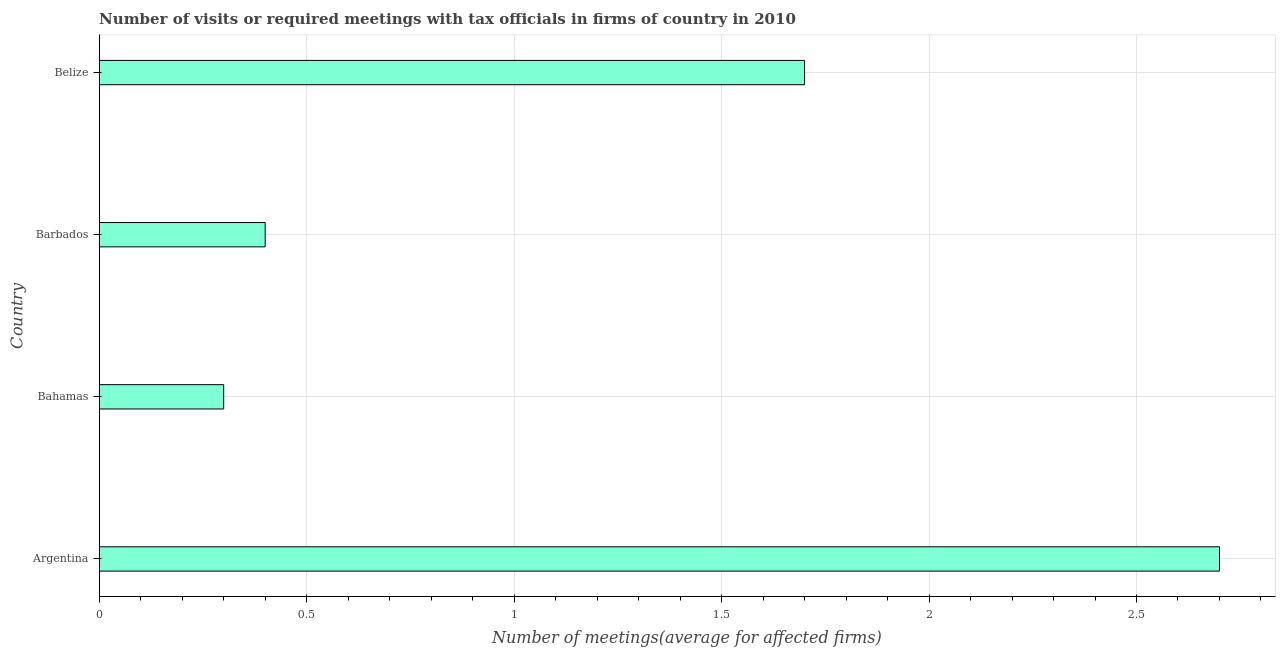Does the graph contain any zero values?
Your response must be concise. No. Does the graph contain grids?
Make the answer very short. Yes. What is the title of the graph?
Ensure brevity in your answer.  Number of visits or required meetings with tax officials in firms of country in 2010. What is the label or title of the X-axis?
Provide a short and direct response. Number of meetings(average for affected firms). What is the number of required meetings with tax officials in Barbados?
Provide a short and direct response. 0.4. Across all countries, what is the minimum number of required meetings with tax officials?
Keep it short and to the point. 0.3. In which country was the number of required meetings with tax officials minimum?
Ensure brevity in your answer.  Bahamas. What is the sum of the number of required meetings with tax officials?
Ensure brevity in your answer.  5.1. What is the difference between the number of required meetings with tax officials in Argentina and Belize?
Your answer should be very brief. 1. What is the average number of required meetings with tax officials per country?
Your response must be concise. 1.27. In how many countries, is the number of required meetings with tax officials greater than 0.9 ?
Provide a short and direct response. 2. Is the number of required meetings with tax officials in Argentina less than that in Belize?
Make the answer very short. No. Is the difference between the number of required meetings with tax officials in Argentina and Belize greater than the difference between any two countries?
Ensure brevity in your answer.  No. Is the sum of the number of required meetings with tax officials in Argentina and Barbados greater than the maximum number of required meetings with tax officials across all countries?
Your answer should be compact. Yes. What is the difference between the highest and the lowest number of required meetings with tax officials?
Your response must be concise. 2.4. In how many countries, is the number of required meetings with tax officials greater than the average number of required meetings with tax officials taken over all countries?
Ensure brevity in your answer.  2. Are all the bars in the graph horizontal?
Give a very brief answer. Yes. How many countries are there in the graph?
Offer a very short reply. 4. Are the values on the major ticks of X-axis written in scientific E-notation?
Offer a terse response. No. What is the Number of meetings(average for affected firms) of Argentina?
Give a very brief answer. 2.7. What is the Number of meetings(average for affected firms) in Belize?
Your answer should be very brief. 1.7. What is the difference between the Number of meetings(average for affected firms) in Argentina and Belize?
Ensure brevity in your answer.  1. What is the difference between the Number of meetings(average for affected firms) in Bahamas and Barbados?
Your answer should be very brief. -0.1. What is the difference between the Number of meetings(average for affected firms) in Bahamas and Belize?
Make the answer very short. -1.4. What is the difference between the Number of meetings(average for affected firms) in Barbados and Belize?
Provide a succinct answer. -1.3. What is the ratio of the Number of meetings(average for affected firms) in Argentina to that in Bahamas?
Your answer should be very brief. 9. What is the ratio of the Number of meetings(average for affected firms) in Argentina to that in Barbados?
Your answer should be compact. 6.75. What is the ratio of the Number of meetings(average for affected firms) in Argentina to that in Belize?
Provide a short and direct response. 1.59. What is the ratio of the Number of meetings(average for affected firms) in Bahamas to that in Barbados?
Your response must be concise. 0.75. What is the ratio of the Number of meetings(average for affected firms) in Bahamas to that in Belize?
Ensure brevity in your answer.  0.18. What is the ratio of the Number of meetings(average for affected firms) in Barbados to that in Belize?
Provide a succinct answer. 0.23. 